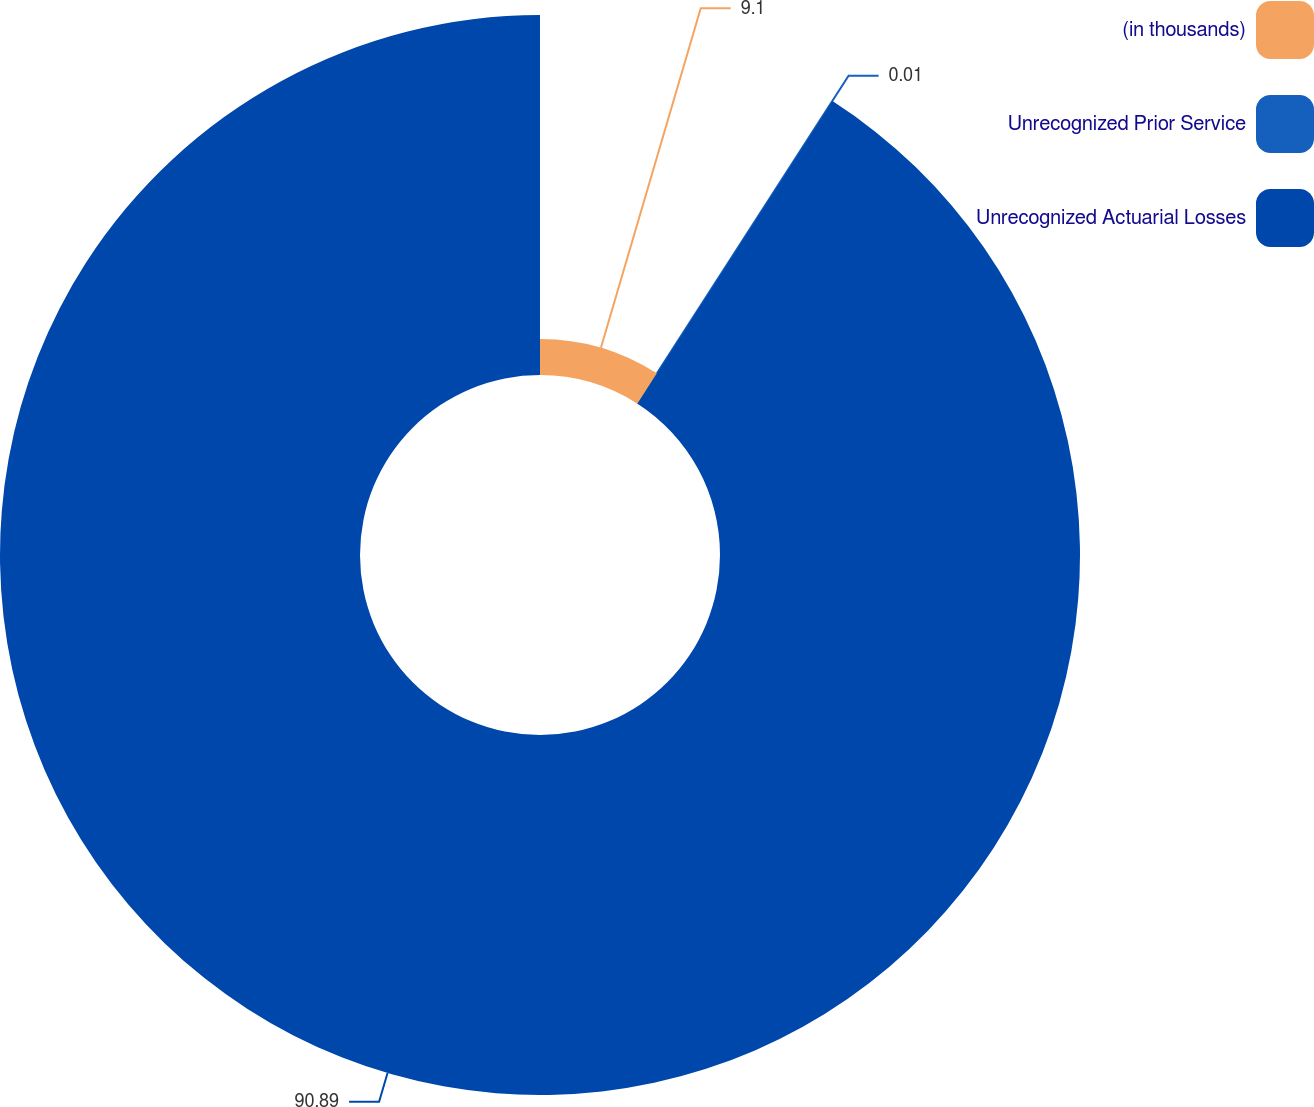<chart> <loc_0><loc_0><loc_500><loc_500><pie_chart><fcel>(in thousands)<fcel>Unrecognized Prior Service<fcel>Unrecognized Actuarial Losses<nl><fcel>9.1%<fcel>0.01%<fcel>90.89%<nl></chart> 